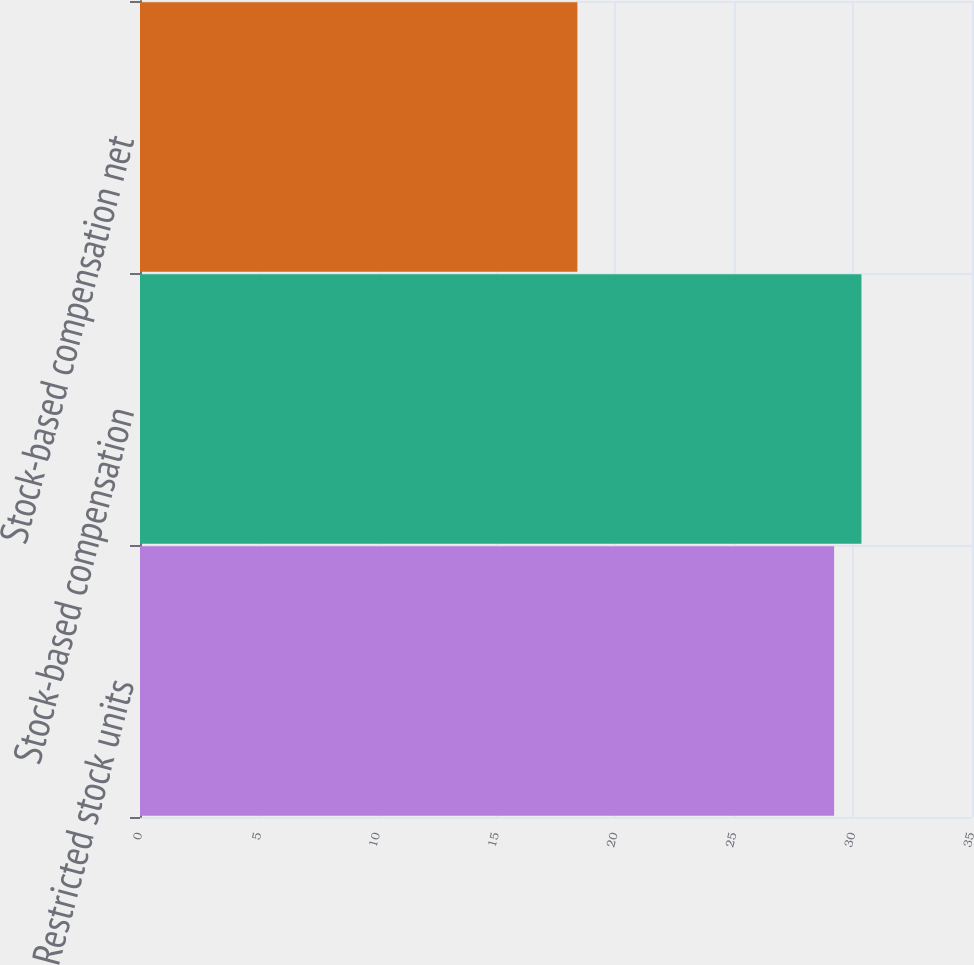<chart> <loc_0><loc_0><loc_500><loc_500><bar_chart><fcel>Restricted stock units<fcel>Stock-based compensation<fcel>Stock-based compensation net<nl><fcel>29.2<fcel>30.35<fcel>18.4<nl></chart> 